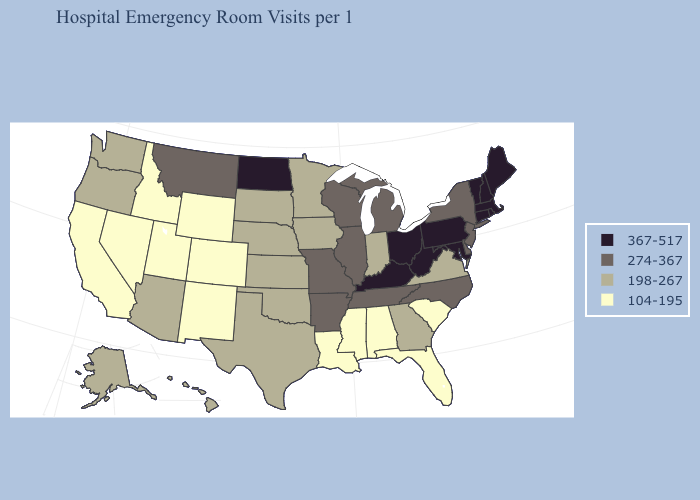Does California have the highest value in the West?
Keep it brief. No. Name the states that have a value in the range 367-517?
Be succinct. Connecticut, Kentucky, Maine, Maryland, Massachusetts, New Hampshire, North Dakota, Ohio, Pennsylvania, Rhode Island, Vermont, West Virginia. Which states hav the highest value in the West?
Answer briefly. Montana. Name the states that have a value in the range 104-195?
Concise answer only. Alabama, California, Colorado, Florida, Idaho, Louisiana, Mississippi, Nevada, New Mexico, South Carolina, Utah, Wyoming. What is the value of Ohio?
Answer briefly. 367-517. What is the value of Virginia?
Short answer required. 198-267. Name the states that have a value in the range 274-367?
Give a very brief answer. Arkansas, Delaware, Illinois, Michigan, Missouri, Montana, New Jersey, New York, North Carolina, Tennessee, Wisconsin. What is the lowest value in the MidWest?
Concise answer only. 198-267. Does Colorado have the highest value in the USA?
Short answer required. No. Does Ohio have the same value as New York?
Keep it brief. No. Does Pennsylvania have the highest value in the USA?
Quick response, please. Yes. What is the lowest value in states that border Maryland?
Concise answer only. 198-267. Among the states that border Vermont , does New Hampshire have the lowest value?
Answer briefly. No. How many symbols are there in the legend?
Keep it brief. 4. What is the lowest value in the USA?
Short answer required. 104-195. 